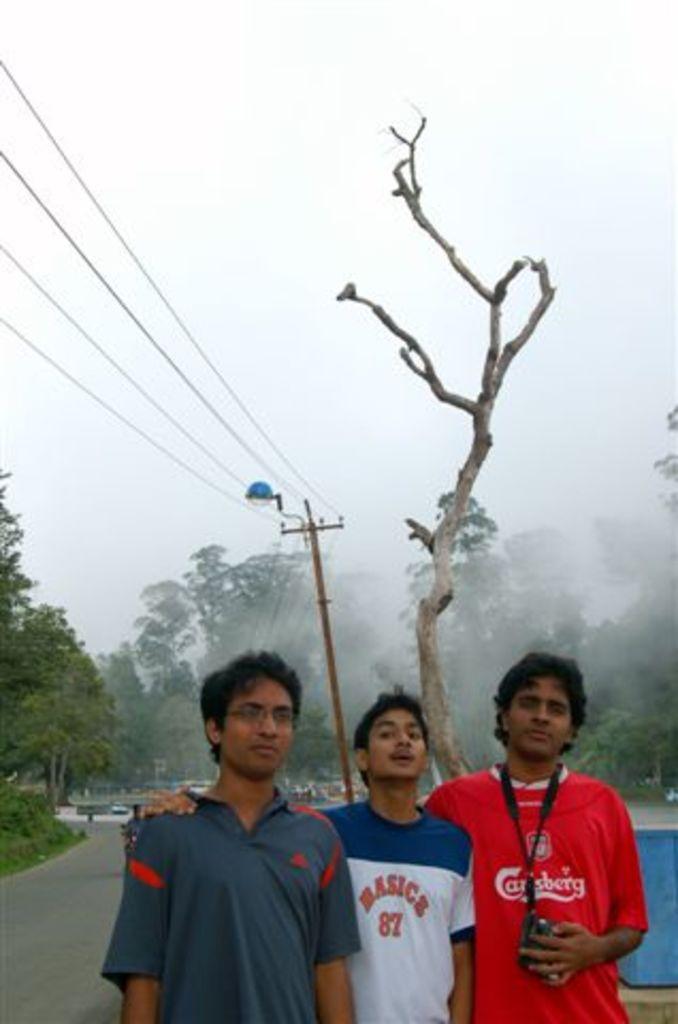What is the number on the middle boys shirt?
Your response must be concise. 87. 